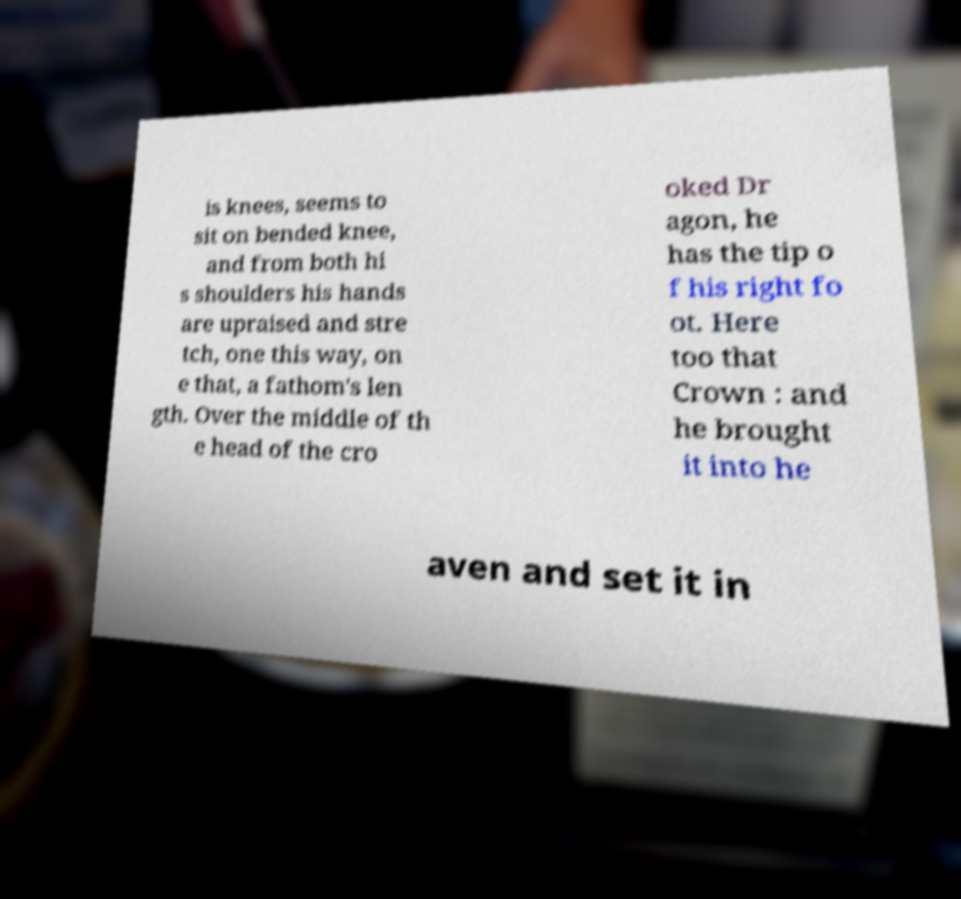Can you accurately transcribe the text from the provided image for me? is knees, seems to sit on bended knee, and from both hi s shoulders his hands are upraised and stre tch, one this way, on e that, a fathom's len gth. Over the middle of th e head of the cro oked Dr agon, he has the tip o f his right fo ot. Here too that Crown : and he brought it into he aven and set it in 